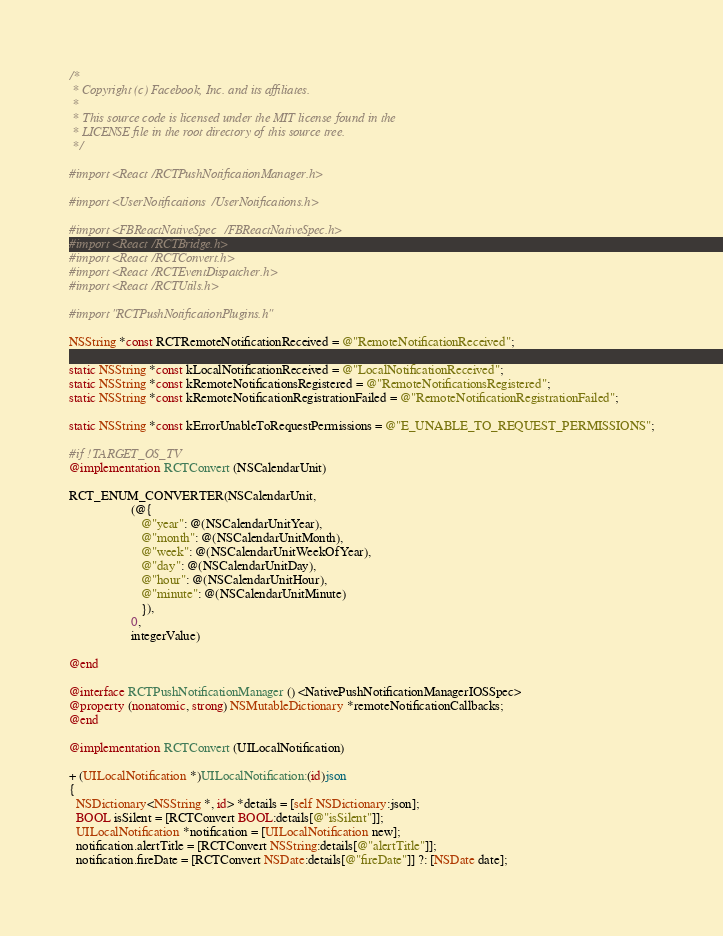Convert code to text. <code><loc_0><loc_0><loc_500><loc_500><_ObjectiveC_>/*
 * Copyright (c) Facebook, Inc. and its affiliates.
 *
 * This source code is licensed under the MIT license found in the
 * LICENSE file in the root directory of this source tree.
 */

#import <React/RCTPushNotificationManager.h>

#import <UserNotifications/UserNotifications.h>

#import <FBReactNativeSpec/FBReactNativeSpec.h>
#import <React/RCTBridge.h>
#import <React/RCTConvert.h>
#import <React/RCTEventDispatcher.h>
#import <React/RCTUtils.h>

#import "RCTPushNotificationPlugins.h"

NSString *const RCTRemoteNotificationReceived = @"RemoteNotificationReceived";

static NSString *const kLocalNotificationReceived = @"LocalNotificationReceived";
static NSString *const kRemoteNotificationsRegistered = @"RemoteNotificationsRegistered";
static NSString *const kRemoteNotificationRegistrationFailed = @"RemoteNotificationRegistrationFailed";

static NSString *const kErrorUnableToRequestPermissions = @"E_UNABLE_TO_REQUEST_PERMISSIONS";

#if !TARGET_OS_TV
@implementation RCTConvert (NSCalendarUnit)

RCT_ENUM_CONVERTER(NSCalendarUnit,
                   (@{
                      @"year": @(NSCalendarUnitYear),
                      @"month": @(NSCalendarUnitMonth),
                      @"week": @(NSCalendarUnitWeekOfYear),
                      @"day": @(NSCalendarUnitDay),
                      @"hour": @(NSCalendarUnitHour),
                      @"minute": @(NSCalendarUnitMinute)
                      }),
                   0,
                   integerValue)

@end

@interface RCTPushNotificationManager () <NativePushNotificationManagerIOSSpec>
@property (nonatomic, strong) NSMutableDictionary *remoteNotificationCallbacks;
@end

@implementation RCTConvert (UILocalNotification)

+ (UILocalNotification *)UILocalNotification:(id)json
{
  NSDictionary<NSString *, id> *details = [self NSDictionary:json];
  BOOL isSilent = [RCTConvert BOOL:details[@"isSilent"]];
  UILocalNotification *notification = [UILocalNotification new];
  notification.alertTitle = [RCTConvert NSString:details[@"alertTitle"]];
  notification.fireDate = [RCTConvert NSDate:details[@"fireDate"]] ?: [NSDate date];</code> 